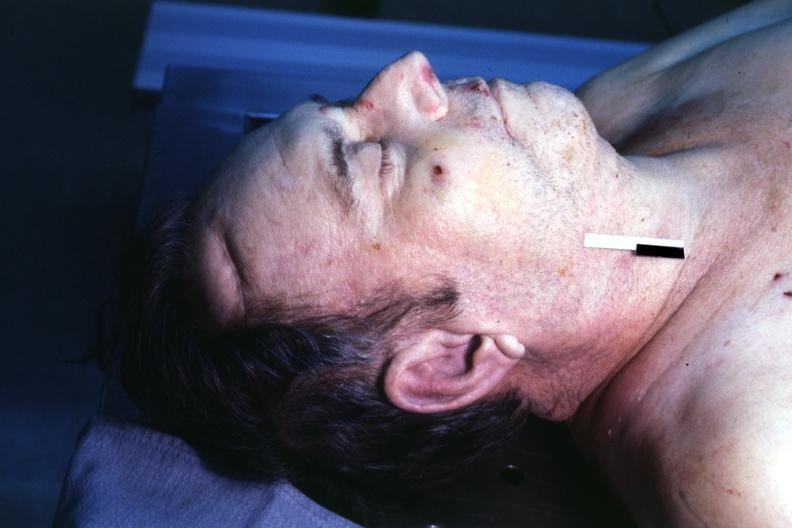does this image show body on autopsy table lesion that supposedly predicts premature coronary disease is easily seen?
Answer the question using a single word or phrase. Yes 